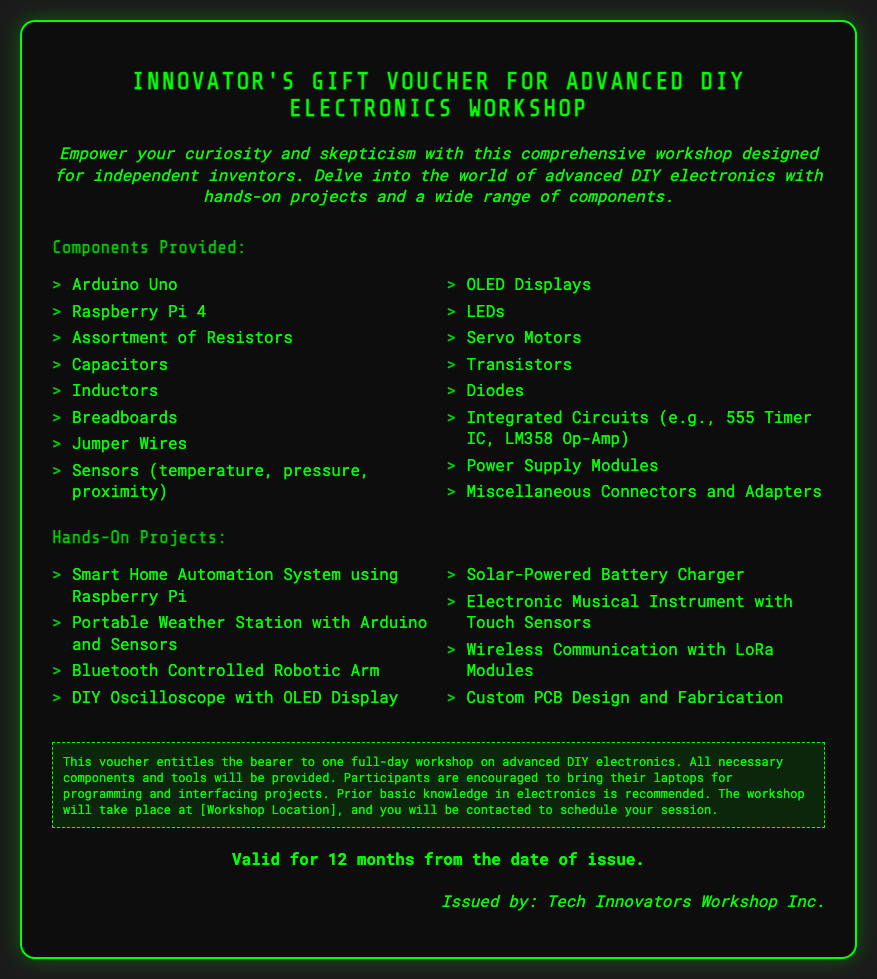What is the title of the workshop? The title of the workshop is stated at the top of the voucher, which is "Innovator's Gift Voucher for Advanced DIY Electronics Workshop."
Answer: Innovator's Gift Voucher for Advanced DIY Electronics Workshop How long is the voucher valid? The validity period of the voucher is specified in the document, stating that it is valid for 12 months from the date of issue.
Answer: 12 months Who issued the voucher? The issuer of the voucher is mentioned at the end of the document, which is "Tech Innovators Workshop Inc."
Answer: Tech Innovators Workshop Inc What major component is included for programming? The document lists key components provided, and the major one for programming is "Raspberry Pi 4."
Answer: Raspberry Pi 4 How many hands-on projects are listed? The number of hands-on projects can be determined by counting the items in the corresponding section, which lists eight projects.
Answer: 8 What type of projects will participants work on? The document specifies the nature of projects, indicating they will work on hands-on projects related to DIY electronics, such as "Smart Home Automation System."
Answer: DIY electronics What is recommended for participants to bring? The document advises participants to bring something specific for programming, which is "laptops."
Answer: laptops What is the background knowledge recommended? The workshop recommends a certain level of understanding before participation, specifically stating the need for "basic knowledge in electronics."
Answer: basic knowledge in electronics 